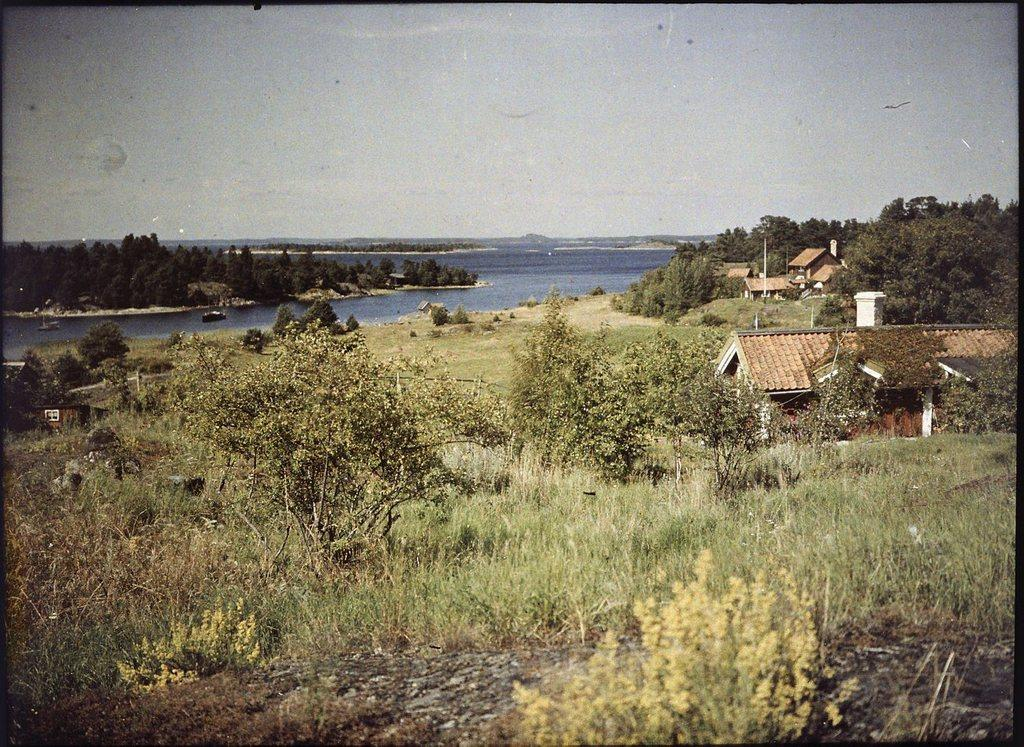What types of vegetation are at the bottom of the image? There are plants and trees at the bottom of the image. What structures are also present at the bottom of the image? There are houses at the bottom of the image. What can be seen behind the plants, trees, and houses? Water is visible behind the plants, trees, and houses. What else is visible behind the water? There are more trees visible behind the water. What is visible at the top of the image? The sky is visible at the top of the image. What type of quilt is being used to cover the water in the image? There is no quilt present in the image; it features plants, trees, houses, water, and the sky. Can you see any stars in the sky in the image? The sky is visible in the image, but there is no indication of stars or any celestial bodies besides the sun. 